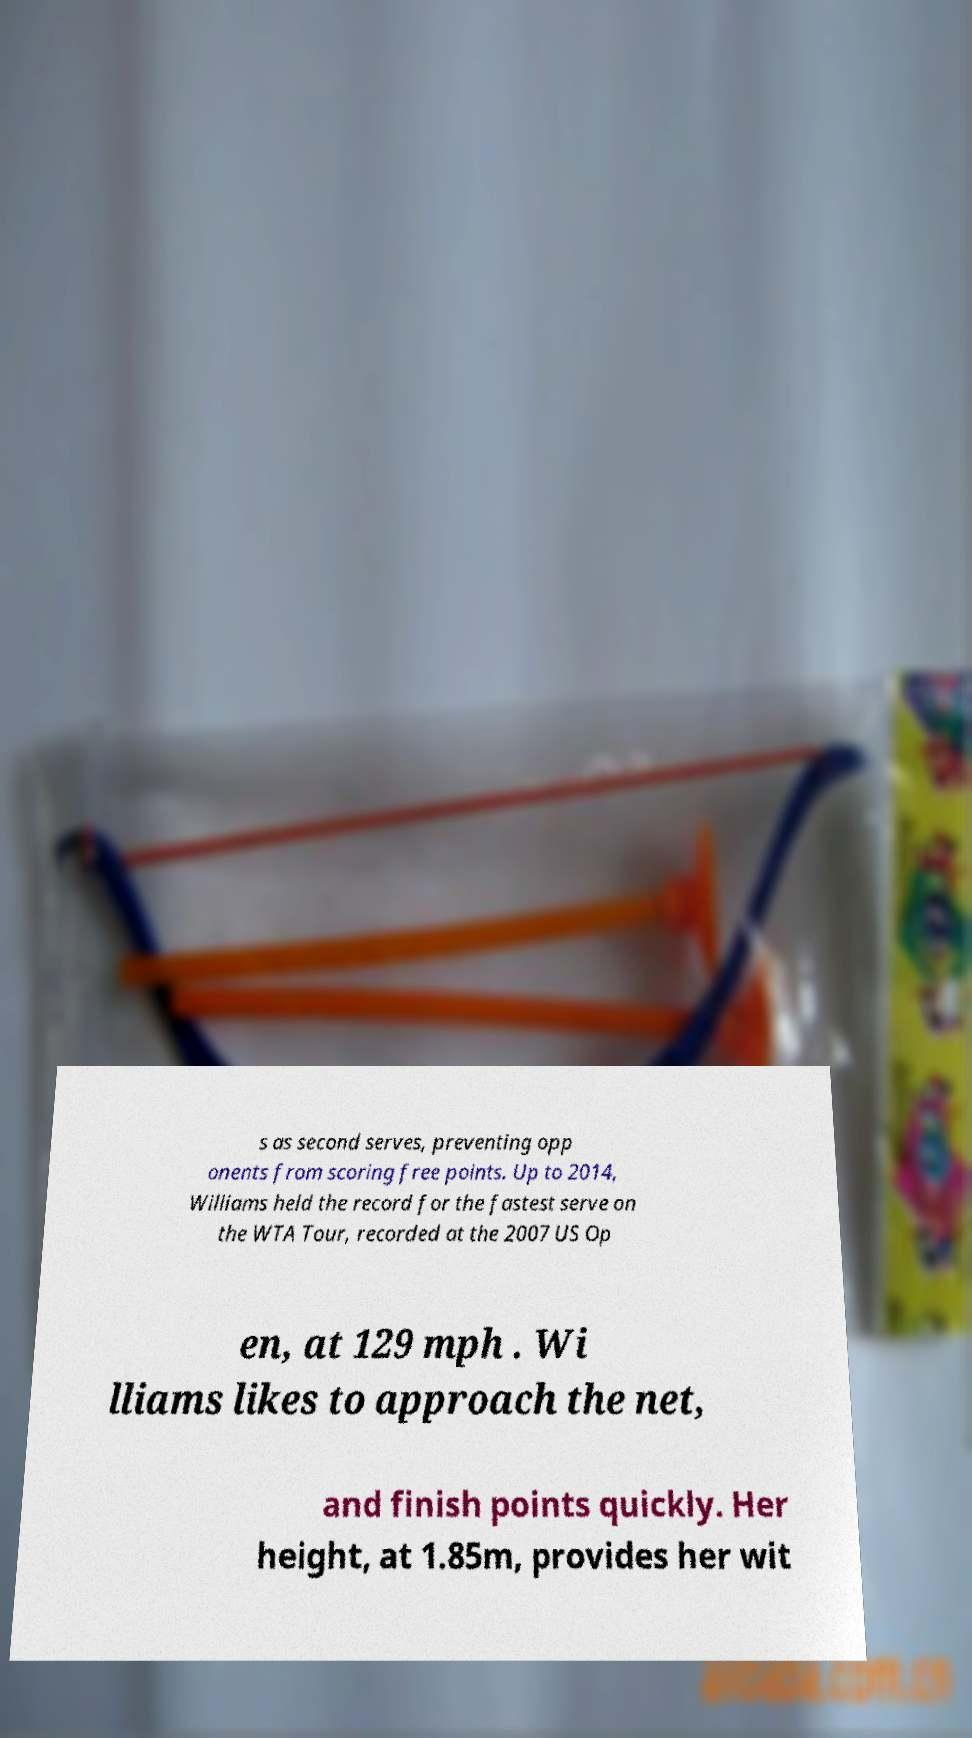I need the written content from this picture converted into text. Can you do that? s as second serves, preventing opp onents from scoring free points. Up to 2014, Williams held the record for the fastest serve on the WTA Tour, recorded at the 2007 US Op en, at 129 mph . Wi lliams likes to approach the net, and finish points quickly. Her height, at 1.85m, provides her wit 